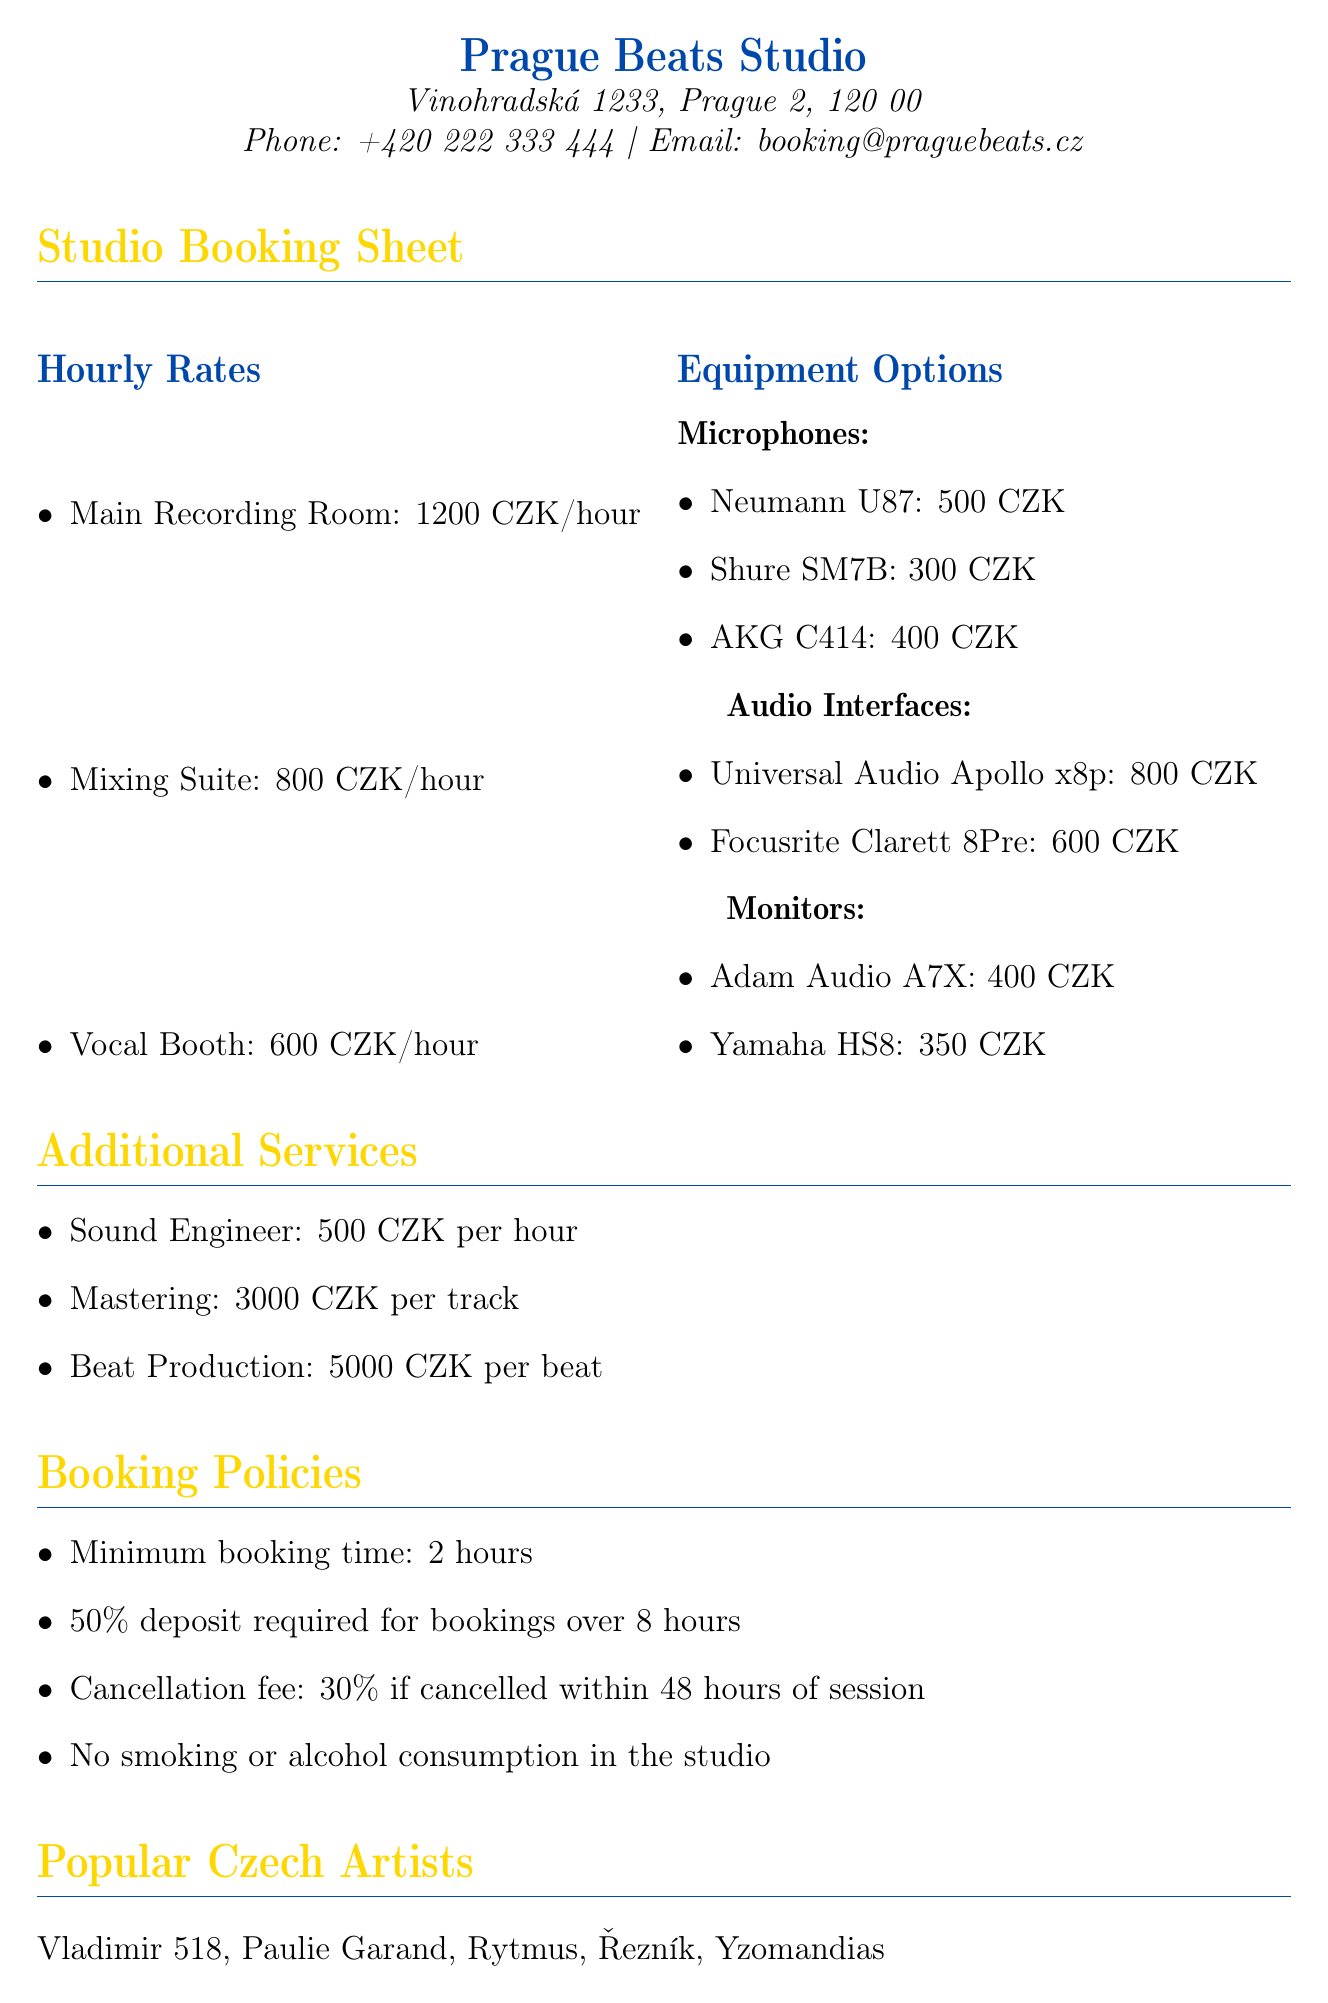What is the address of the studio? The address is listed in the contact information section of the document.
Answer: Vinohradská 1233, Prague 2, 120 00 How much does it cost to rent the Main Recording Room per hour? The hourly rate for the Main Recording Room is specified under the hourly rates section.
Answer: 1200 CZK What type of microphones are available for rent? The document specifies available equipment options under the microphones category.
Answer: Neumann U87, Shure SM7B, AKG C414 What is the cancellation fee if cancelled within 48 hours? The booking policies section outlines the cancellation fee if the booking is cancelled within this timeframe.
Answer: 30% Which popular Czech artist is mentioned in the document? The popular Czech artists section lists several artists.
Answer: Vladimir 518 What is the rental fee for the Yamaha HS8 monitor? The fee for the Yamaha HS8 is detailed in the equipment options section under monitors.
Answer: 350 CZK How many hours is the minimum booking time? The booking policies section specifies the minimum booking time required.
Answer: 2 hours What additional service costs 3000 CZK? The additional services section lists services with their respective rates, including mastering.
Answer: Mastering Which event took place in August 2023? The upcoming local music events section lists events with their dates.
Answer: Hip Hop Kemp 